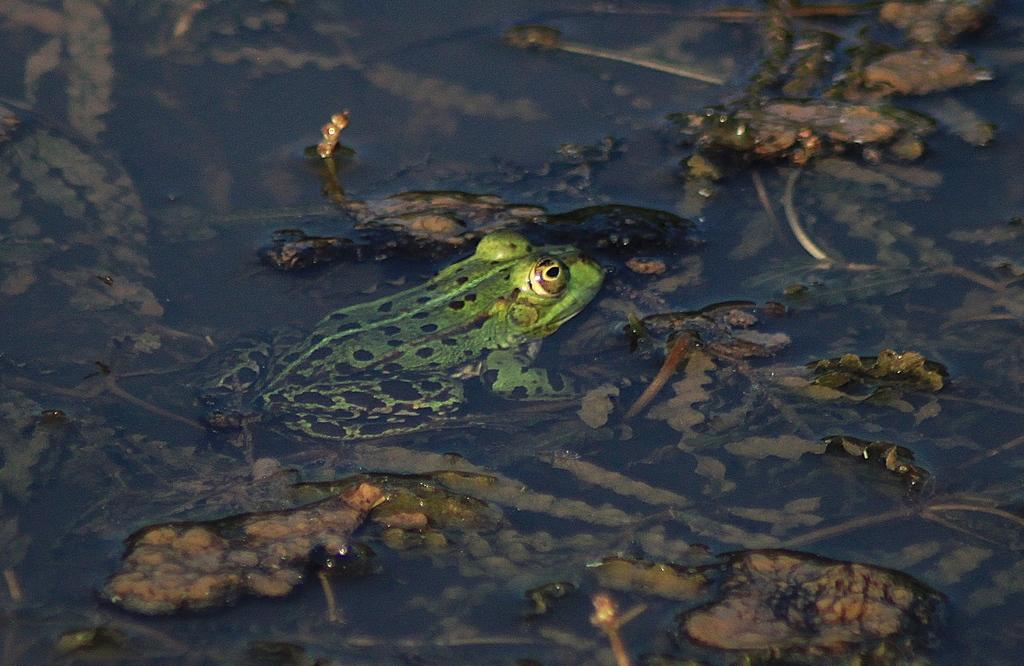What animal is present in the image? There is a frog in the image. Where is the frog located? The frog is in the water. Can you see any person interacting with the frog in the image? There is no person present in the image. 